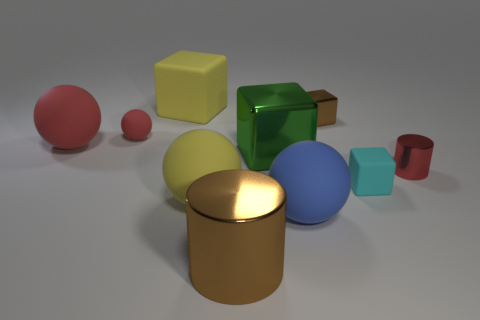There is a big object in front of the large blue rubber ball; what number of red things are right of it?
Ensure brevity in your answer.  1. Is the number of red cylinders greater than the number of gray matte blocks?
Your answer should be compact. Yes. Is the material of the tiny sphere the same as the tiny red cylinder?
Your response must be concise. No. Is the number of red things behind the yellow cube the same as the number of cyan rubber blocks?
Offer a terse response. No. What number of tiny brown things are made of the same material as the big red ball?
Ensure brevity in your answer.  0. Are there fewer big blue matte things than purple shiny things?
Provide a succinct answer. No. Does the tiny metal thing behind the tiny red metallic cylinder have the same color as the small ball?
Provide a short and direct response. No. There is a large green block that is left of the block that is in front of the small metal cylinder; what number of yellow things are behind it?
Provide a succinct answer. 1. There is a tiny cylinder; what number of brown things are to the right of it?
Your answer should be compact. 0. What color is the small rubber thing that is the same shape as the big blue thing?
Offer a very short reply. Red. 